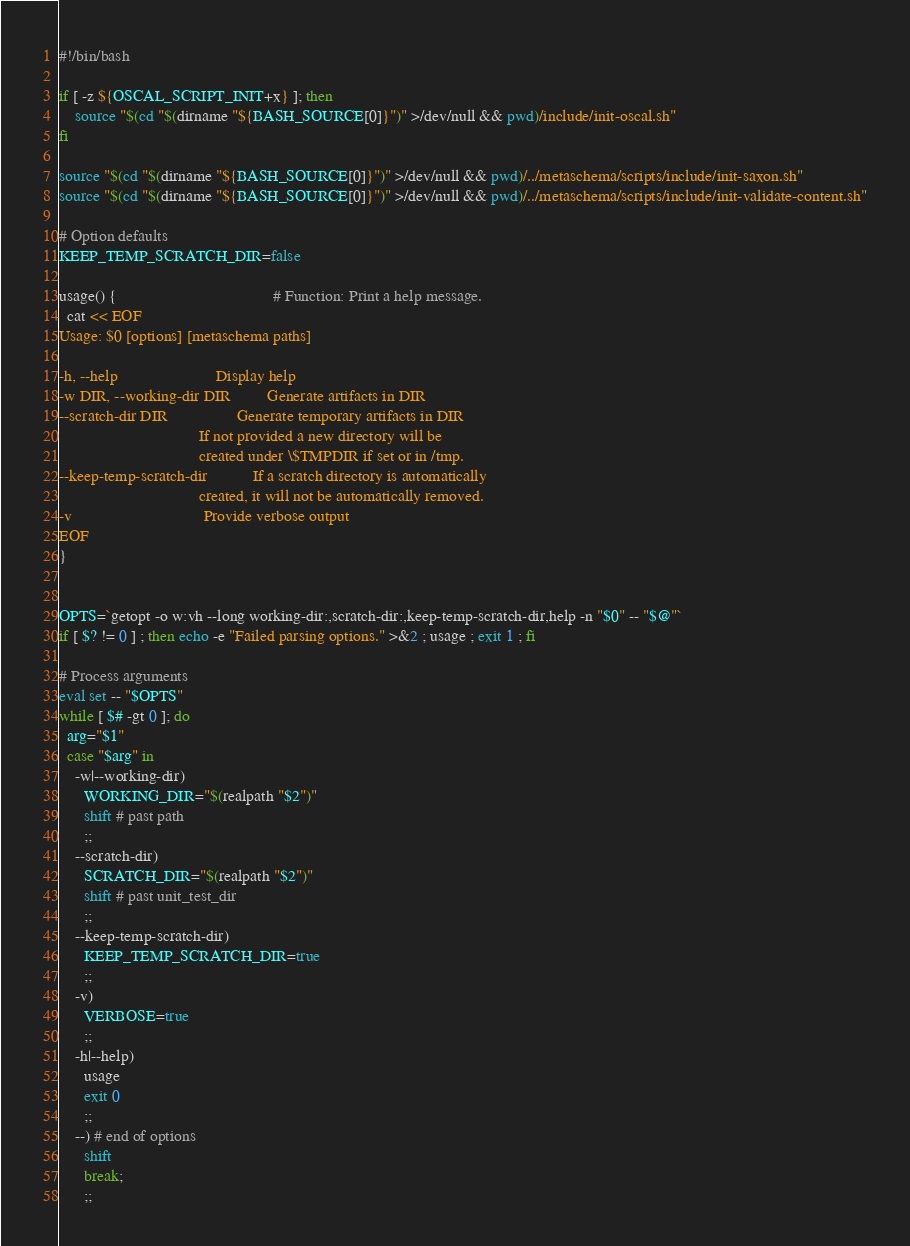Convert code to text. <code><loc_0><loc_0><loc_500><loc_500><_Bash_>#!/bin/bash

if [ -z ${OSCAL_SCRIPT_INIT+x} ]; then
    source "$(cd "$(dirname "${BASH_SOURCE[0]}")" >/dev/null && pwd)/include/init-oscal.sh"
fi

source "$(cd "$(dirname "${BASH_SOURCE[0]}")" >/dev/null && pwd)/../metaschema/scripts/include/init-saxon.sh"
source "$(cd "$(dirname "${BASH_SOURCE[0]}")" >/dev/null && pwd)/../metaschema/scripts/include/init-validate-content.sh"

# Option defaults
KEEP_TEMP_SCRATCH_DIR=false

usage() {                                      # Function: Print a help message.
  cat << EOF
Usage: $0 [options] [metaschema paths]

-h, --help                        Display help
-w DIR, --working-dir DIR         Generate artifacts in DIR
--scratch-dir DIR                 Generate temporary artifacts in DIR
                                  If not provided a new directory will be
                                  created under \$TMPDIR if set or in /tmp.
--keep-temp-scratch-dir           If a scratch directory is automatically
                                  created, it will not be automatically removed.
-v                                Provide verbose output
EOF
}


OPTS=`getopt -o w:vh --long working-dir:,scratch-dir:,keep-temp-scratch-dir,help -n "$0" -- "$@"`
if [ $? != 0 ] ; then echo -e "Failed parsing options." >&2 ; usage ; exit 1 ; fi

# Process arguments
eval set -- "$OPTS"
while [ $# -gt 0 ]; do
  arg="$1"
  case "$arg" in
    -w|--working-dir)
      WORKING_DIR="$(realpath "$2")"
      shift # past path
      ;;
    --scratch-dir)
      SCRATCH_DIR="$(realpath "$2")"
      shift # past unit_test_dir
      ;;
    --keep-temp-scratch-dir)
      KEEP_TEMP_SCRATCH_DIR=true
      ;;
    -v)
      VERBOSE=true
      ;;
    -h|--help)
      usage
      exit 0
      ;;
    --) # end of options
      shift
      break;
      ;;</code> 